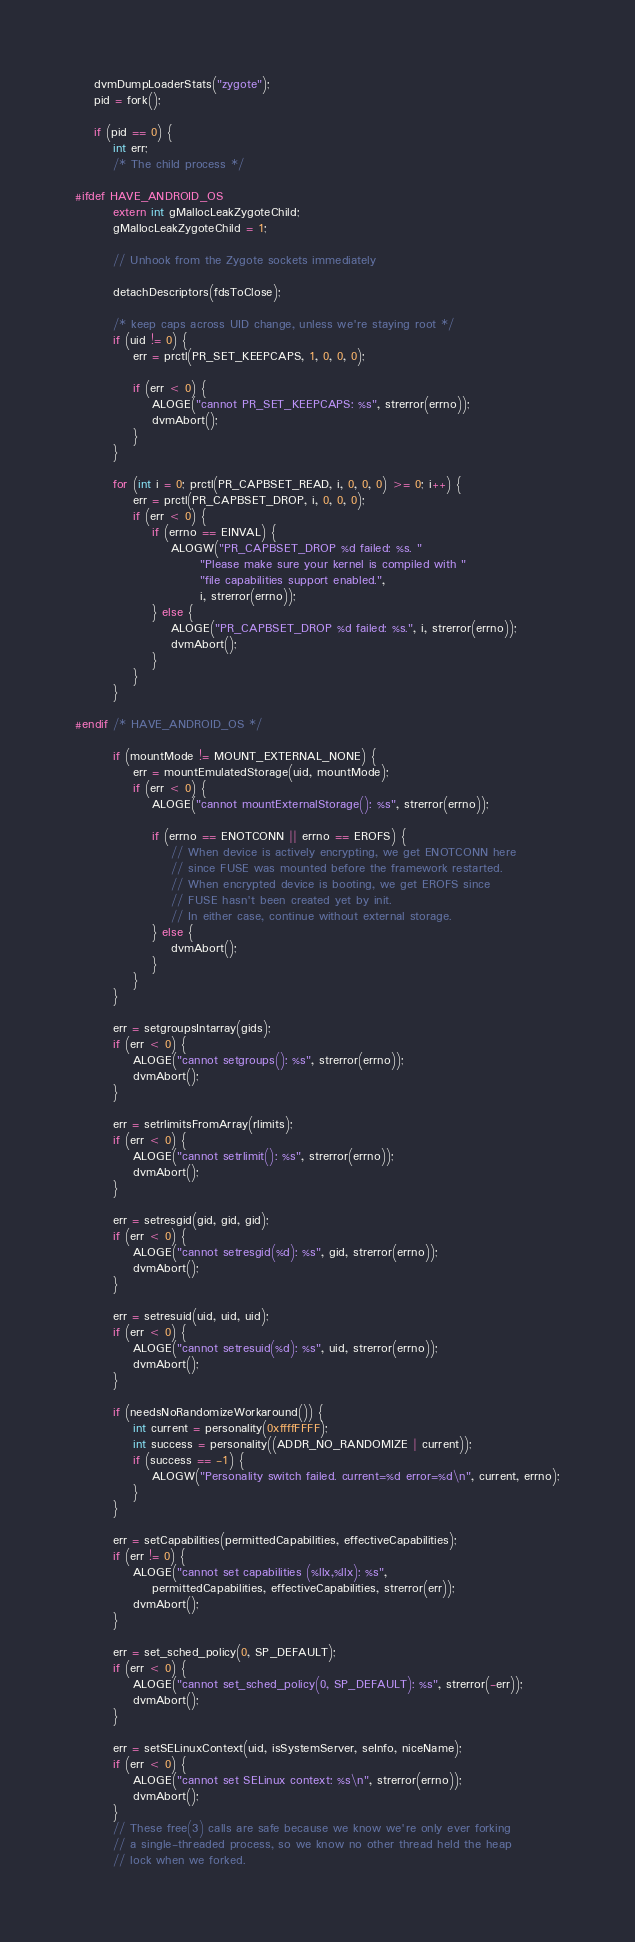<code> <loc_0><loc_0><loc_500><loc_500><_C++_>    dvmDumpLoaderStats("zygote");
    pid = fork();

    if (pid == 0) {
        int err;
        /* The child process */

#ifdef HAVE_ANDROID_OS
        extern int gMallocLeakZygoteChild;
        gMallocLeakZygoteChild = 1;

        // Unhook from the Zygote sockets immediately

        detachDescriptors(fdsToClose);

        /* keep caps across UID change, unless we're staying root */
        if (uid != 0) {
            err = prctl(PR_SET_KEEPCAPS, 1, 0, 0, 0);

            if (err < 0) {
                ALOGE("cannot PR_SET_KEEPCAPS: %s", strerror(errno));
                dvmAbort();
            }
        }

        for (int i = 0; prctl(PR_CAPBSET_READ, i, 0, 0, 0) >= 0; i++) {
            err = prctl(PR_CAPBSET_DROP, i, 0, 0, 0);
            if (err < 0) {
                if (errno == EINVAL) {
                    ALOGW("PR_CAPBSET_DROP %d failed: %s. "
                          "Please make sure your kernel is compiled with "
                          "file capabilities support enabled.",
                          i, strerror(errno));
                } else {
                    ALOGE("PR_CAPBSET_DROP %d failed: %s.", i, strerror(errno));
                    dvmAbort();
                }
            }
        }

#endif /* HAVE_ANDROID_OS */

        if (mountMode != MOUNT_EXTERNAL_NONE) {
            err = mountEmulatedStorage(uid, mountMode);
            if (err < 0) {
                ALOGE("cannot mountExternalStorage(): %s", strerror(errno));

                if (errno == ENOTCONN || errno == EROFS) {
                    // When device is actively encrypting, we get ENOTCONN here
                    // since FUSE was mounted before the framework restarted.
                    // When encrypted device is booting, we get EROFS since
                    // FUSE hasn't been created yet by init.
                    // In either case, continue without external storage.
                } else {
                    dvmAbort();
                }
            }
        }

        err = setgroupsIntarray(gids);
        if (err < 0) {
            ALOGE("cannot setgroups(): %s", strerror(errno));
            dvmAbort();
        }

        err = setrlimitsFromArray(rlimits);
        if (err < 0) {
            ALOGE("cannot setrlimit(): %s", strerror(errno));
            dvmAbort();
        }

        err = setresgid(gid, gid, gid);
        if (err < 0) {
            ALOGE("cannot setresgid(%d): %s", gid, strerror(errno));
            dvmAbort();
        }

        err = setresuid(uid, uid, uid);
        if (err < 0) {
            ALOGE("cannot setresuid(%d): %s", uid, strerror(errno));
            dvmAbort();
        }

        if (needsNoRandomizeWorkaround()) {
            int current = personality(0xffffFFFF);
            int success = personality((ADDR_NO_RANDOMIZE | current));
            if (success == -1) {
                ALOGW("Personality switch failed. current=%d error=%d\n", current, errno);
            }
        }

        err = setCapabilities(permittedCapabilities, effectiveCapabilities);
        if (err != 0) {
            ALOGE("cannot set capabilities (%llx,%llx): %s",
                permittedCapabilities, effectiveCapabilities, strerror(err));
            dvmAbort();
        }

        err = set_sched_policy(0, SP_DEFAULT);
        if (err < 0) {
            ALOGE("cannot set_sched_policy(0, SP_DEFAULT): %s", strerror(-err));
            dvmAbort();
        }

        err = setSELinuxContext(uid, isSystemServer, seInfo, niceName);
        if (err < 0) {
            ALOGE("cannot set SELinux context: %s\n", strerror(errno));
            dvmAbort();
        }
        // These free(3) calls are safe because we know we're only ever forking
        // a single-threaded process, so we know no other thread held the heap
        // lock when we forked.</code> 